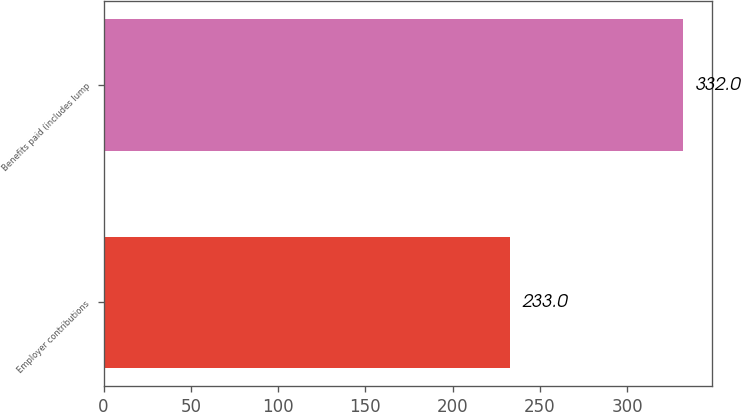Convert chart. <chart><loc_0><loc_0><loc_500><loc_500><bar_chart><fcel>Employer contributions<fcel>Benefits paid (includes lump<nl><fcel>233<fcel>332<nl></chart> 